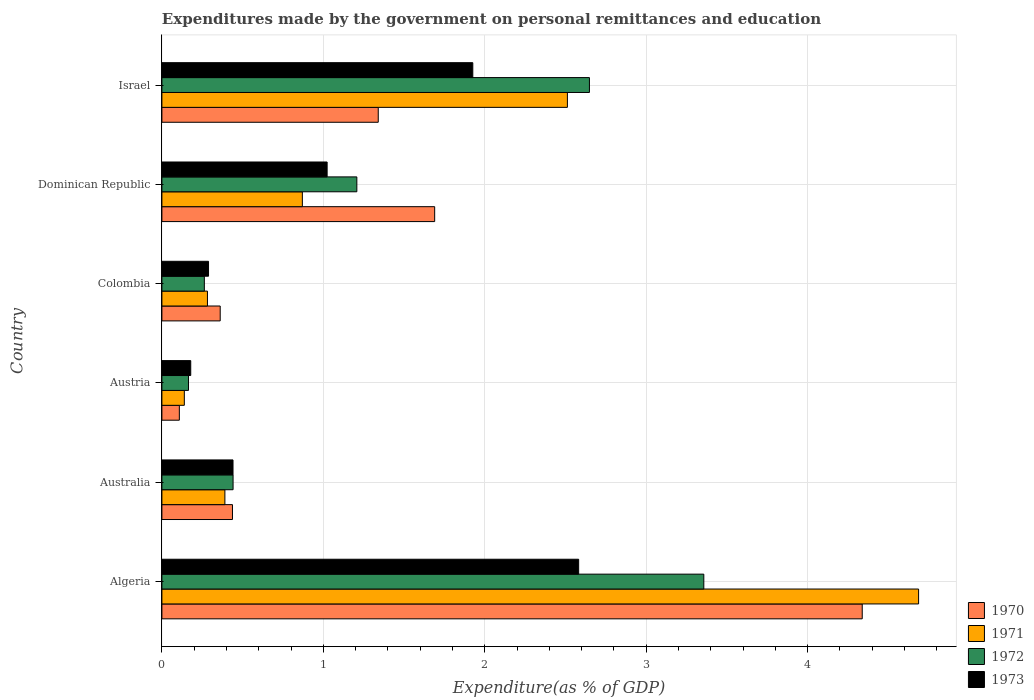Are the number of bars per tick equal to the number of legend labels?
Provide a succinct answer. Yes. How many bars are there on the 6th tick from the top?
Provide a short and direct response. 4. How many bars are there on the 4th tick from the bottom?
Offer a terse response. 4. What is the label of the 4th group of bars from the top?
Offer a very short reply. Austria. What is the expenditures made by the government on personal remittances and education in 1970 in Dominican Republic?
Your answer should be compact. 1.69. Across all countries, what is the maximum expenditures made by the government on personal remittances and education in 1973?
Ensure brevity in your answer.  2.58. Across all countries, what is the minimum expenditures made by the government on personal remittances and education in 1972?
Provide a short and direct response. 0.16. In which country was the expenditures made by the government on personal remittances and education in 1972 maximum?
Keep it short and to the point. Algeria. In which country was the expenditures made by the government on personal remittances and education in 1972 minimum?
Your answer should be very brief. Austria. What is the total expenditures made by the government on personal remittances and education in 1973 in the graph?
Keep it short and to the point. 6.44. What is the difference between the expenditures made by the government on personal remittances and education in 1970 in Australia and that in Austria?
Your answer should be very brief. 0.33. What is the difference between the expenditures made by the government on personal remittances and education in 1971 in Colombia and the expenditures made by the government on personal remittances and education in 1970 in Australia?
Offer a terse response. -0.16. What is the average expenditures made by the government on personal remittances and education in 1973 per country?
Give a very brief answer. 1.07. What is the difference between the expenditures made by the government on personal remittances and education in 1971 and expenditures made by the government on personal remittances and education in 1972 in Algeria?
Make the answer very short. 1.33. What is the ratio of the expenditures made by the government on personal remittances and education in 1971 in Australia to that in Colombia?
Your answer should be very brief. 1.38. Is the expenditures made by the government on personal remittances and education in 1970 in Australia less than that in Austria?
Keep it short and to the point. No. Is the difference between the expenditures made by the government on personal remittances and education in 1971 in Colombia and Dominican Republic greater than the difference between the expenditures made by the government on personal remittances and education in 1972 in Colombia and Dominican Republic?
Offer a very short reply. Yes. What is the difference between the highest and the second highest expenditures made by the government on personal remittances and education in 1971?
Keep it short and to the point. 2.18. What is the difference between the highest and the lowest expenditures made by the government on personal remittances and education in 1970?
Your response must be concise. 4.23. Is the sum of the expenditures made by the government on personal remittances and education in 1973 in Australia and Dominican Republic greater than the maximum expenditures made by the government on personal remittances and education in 1970 across all countries?
Offer a very short reply. No. What does the 3rd bar from the top in Australia represents?
Your answer should be compact. 1971. Are all the bars in the graph horizontal?
Keep it short and to the point. Yes. How many countries are there in the graph?
Provide a short and direct response. 6. What is the difference between two consecutive major ticks on the X-axis?
Make the answer very short. 1. Does the graph contain any zero values?
Keep it short and to the point. No. How many legend labels are there?
Your response must be concise. 4. How are the legend labels stacked?
Offer a terse response. Vertical. What is the title of the graph?
Your answer should be compact. Expenditures made by the government on personal remittances and education. What is the label or title of the X-axis?
Your response must be concise. Expenditure(as % of GDP). What is the Expenditure(as % of GDP) of 1970 in Algeria?
Provide a succinct answer. 4.34. What is the Expenditure(as % of GDP) in 1971 in Algeria?
Provide a short and direct response. 4.69. What is the Expenditure(as % of GDP) in 1972 in Algeria?
Give a very brief answer. 3.36. What is the Expenditure(as % of GDP) of 1973 in Algeria?
Offer a terse response. 2.58. What is the Expenditure(as % of GDP) of 1970 in Australia?
Provide a succinct answer. 0.44. What is the Expenditure(as % of GDP) of 1971 in Australia?
Provide a succinct answer. 0.39. What is the Expenditure(as % of GDP) of 1972 in Australia?
Keep it short and to the point. 0.44. What is the Expenditure(as % of GDP) in 1973 in Australia?
Your response must be concise. 0.44. What is the Expenditure(as % of GDP) of 1970 in Austria?
Your answer should be very brief. 0.11. What is the Expenditure(as % of GDP) in 1971 in Austria?
Ensure brevity in your answer.  0.14. What is the Expenditure(as % of GDP) of 1972 in Austria?
Make the answer very short. 0.16. What is the Expenditure(as % of GDP) of 1973 in Austria?
Make the answer very short. 0.18. What is the Expenditure(as % of GDP) in 1970 in Colombia?
Your response must be concise. 0.36. What is the Expenditure(as % of GDP) in 1971 in Colombia?
Keep it short and to the point. 0.28. What is the Expenditure(as % of GDP) in 1972 in Colombia?
Keep it short and to the point. 0.26. What is the Expenditure(as % of GDP) in 1973 in Colombia?
Keep it short and to the point. 0.29. What is the Expenditure(as % of GDP) in 1970 in Dominican Republic?
Give a very brief answer. 1.69. What is the Expenditure(as % of GDP) of 1971 in Dominican Republic?
Your response must be concise. 0.87. What is the Expenditure(as % of GDP) of 1972 in Dominican Republic?
Your answer should be compact. 1.21. What is the Expenditure(as % of GDP) of 1973 in Dominican Republic?
Your answer should be very brief. 1.02. What is the Expenditure(as % of GDP) of 1970 in Israel?
Offer a terse response. 1.34. What is the Expenditure(as % of GDP) in 1971 in Israel?
Provide a short and direct response. 2.51. What is the Expenditure(as % of GDP) of 1972 in Israel?
Offer a terse response. 2.65. What is the Expenditure(as % of GDP) of 1973 in Israel?
Offer a terse response. 1.93. Across all countries, what is the maximum Expenditure(as % of GDP) in 1970?
Provide a succinct answer. 4.34. Across all countries, what is the maximum Expenditure(as % of GDP) of 1971?
Provide a short and direct response. 4.69. Across all countries, what is the maximum Expenditure(as % of GDP) in 1972?
Your answer should be compact. 3.36. Across all countries, what is the maximum Expenditure(as % of GDP) in 1973?
Offer a terse response. 2.58. Across all countries, what is the minimum Expenditure(as % of GDP) of 1970?
Give a very brief answer. 0.11. Across all countries, what is the minimum Expenditure(as % of GDP) of 1971?
Make the answer very short. 0.14. Across all countries, what is the minimum Expenditure(as % of GDP) in 1972?
Provide a short and direct response. 0.16. Across all countries, what is the minimum Expenditure(as % of GDP) of 1973?
Make the answer very short. 0.18. What is the total Expenditure(as % of GDP) of 1970 in the graph?
Your answer should be compact. 8.27. What is the total Expenditure(as % of GDP) in 1971 in the graph?
Keep it short and to the point. 8.88. What is the total Expenditure(as % of GDP) of 1972 in the graph?
Offer a very short reply. 8.08. What is the total Expenditure(as % of GDP) in 1973 in the graph?
Ensure brevity in your answer.  6.44. What is the difference between the Expenditure(as % of GDP) in 1970 in Algeria and that in Australia?
Your response must be concise. 3.9. What is the difference between the Expenditure(as % of GDP) in 1971 in Algeria and that in Australia?
Your answer should be very brief. 4.3. What is the difference between the Expenditure(as % of GDP) of 1972 in Algeria and that in Australia?
Your response must be concise. 2.92. What is the difference between the Expenditure(as % of GDP) in 1973 in Algeria and that in Australia?
Keep it short and to the point. 2.14. What is the difference between the Expenditure(as % of GDP) in 1970 in Algeria and that in Austria?
Offer a terse response. 4.23. What is the difference between the Expenditure(as % of GDP) of 1971 in Algeria and that in Austria?
Provide a succinct answer. 4.55. What is the difference between the Expenditure(as % of GDP) in 1972 in Algeria and that in Austria?
Offer a terse response. 3.19. What is the difference between the Expenditure(as % of GDP) in 1973 in Algeria and that in Austria?
Your answer should be compact. 2.4. What is the difference between the Expenditure(as % of GDP) in 1970 in Algeria and that in Colombia?
Make the answer very short. 3.98. What is the difference between the Expenditure(as % of GDP) in 1971 in Algeria and that in Colombia?
Make the answer very short. 4.41. What is the difference between the Expenditure(as % of GDP) in 1972 in Algeria and that in Colombia?
Your answer should be compact. 3.09. What is the difference between the Expenditure(as % of GDP) in 1973 in Algeria and that in Colombia?
Provide a succinct answer. 2.29. What is the difference between the Expenditure(as % of GDP) in 1970 in Algeria and that in Dominican Republic?
Provide a succinct answer. 2.65. What is the difference between the Expenditure(as % of GDP) of 1971 in Algeria and that in Dominican Republic?
Offer a terse response. 3.82. What is the difference between the Expenditure(as % of GDP) of 1972 in Algeria and that in Dominican Republic?
Your response must be concise. 2.15. What is the difference between the Expenditure(as % of GDP) in 1973 in Algeria and that in Dominican Republic?
Ensure brevity in your answer.  1.56. What is the difference between the Expenditure(as % of GDP) of 1970 in Algeria and that in Israel?
Make the answer very short. 3. What is the difference between the Expenditure(as % of GDP) of 1971 in Algeria and that in Israel?
Give a very brief answer. 2.18. What is the difference between the Expenditure(as % of GDP) of 1972 in Algeria and that in Israel?
Offer a terse response. 0.71. What is the difference between the Expenditure(as % of GDP) in 1973 in Algeria and that in Israel?
Offer a very short reply. 0.66. What is the difference between the Expenditure(as % of GDP) in 1970 in Australia and that in Austria?
Ensure brevity in your answer.  0.33. What is the difference between the Expenditure(as % of GDP) in 1971 in Australia and that in Austria?
Ensure brevity in your answer.  0.25. What is the difference between the Expenditure(as % of GDP) in 1972 in Australia and that in Austria?
Make the answer very short. 0.28. What is the difference between the Expenditure(as % of GDP) in 1973 in Australia and that in Austria?
Offer a very short reply. 0.26. What is the difference between the Expenditure(as % of GDP) in 1970 in Australia and that in Colombia?
Offer a terse response. 0.08. What is the difference between the Expenditure(as % of GDP) of 1971 in Australia and that in Colombia?
Ensure brevity in your answer.  0.11. What is the difference between the Expenditure(as % of GDP) in 1972 in Australia and that in Colombia?
Ensure brevity in your answer.  0.18. What is the difference between the Expenditure(as % of GDP) of 1973 in Australia and that in Colombia?
Make the answer very short. 0.15. What is the difference between the Expenditure(as % of GDP) in 1970 in Australia and that in Dominican Republic?
Offer a very short reply. -1.25. What is the difference between the Expenditure(as % of GDP) of 1971 in Australia and that in Dominican Republic?
Make the answer very short. -0.48. What is the difference between the Expenditure(as % of GDP) in 1972 in Australia and that in Dominican Republic?
Make the answer very short. -0.77. What is the difference between the Expenditure(as % of GDP) in 1973 in Australia and that in Dominican Republic?
Provide a succinct answer. -0.58. What is the difference between the Expenditure(as % of GDP) in 1970 in Australia and that in Israel?
Your answer should be very brief. -0.9. What is the difference between the Expenditure(as % of GDP) of 1971 in Australia and that in Israel?
Offer a very short reply. -2.12. What is the difference between the Expenditure(as % of GDP) in 1972 in Australia and that in Israel?
Make the answer very short. -2.21. What is the difference between the Expenditure(as % of GDP) of 1973 in Australia and that in Israel?
Your response must be concise. -1.49. What is the difference between the Expenditure(as % of GDP) in 1970 in Austria and that in Colombia?
Provide a short and direct response. -0.25. What is the difference between the Expenditure(as % of GDP) of 1971 in Austria and that in Colombia?
Offer a very short reply. -0.14. What is the difference between the Expenditure(as % of GDP) of 1972 in Austria and that in Colombia?
Keep it short and to the point. -0.1. What is the difference between the Expenditure(as % of GDP) in 1973 in Austria and that in Colombia?
Ensure brevity in your answer.  -0.11. What is the difference between the Expenditure(as % of GDP) in 1970 in Austria and that in Dominican Republic?
Your answer should be very brief. -1.58. What is the difference between the Expenditure(as % of GDP) in 1971 in Austria and that in Dominican Republic?
Keep it short and to the point. -0.73. What is the difference between the Expenditure(as % of GDP) in 1972 in Austria and that in Dominican Republic?
Offer a terse response. -1.04. What is the difference between the Expenditure(as % of GDP) of 1973 in Austria and that in Dominican Republic?
Keep it short and to the point. -0.84. What is the difference between the Expenditure(as % of GDP) in 1970 in Austria and that in Israel?
Keep it short and to the point. -1.23. What is the difference between the Expenditure(as % of GDP) of 1971 in Austria and that in Israel?
Ensure brevity in your answer.  -2.37. What is the difference between the Expenditure(as % of GDP) of 1972 in Austria and that in Israel?
Your answer should be compact. -2.48. What is the difference between the Expenditure(as % of GDP) in 1973 in Austria and that in Israel?
Offer a terse response. -1.75. What is the difference between the Expenditure(as % of GDP) of 1970 in Colombia and that in Dominican Republic?
Offer a very short reply. -1.33. What is the difference between the Expenditure(as % of GDP) of 1971 in Colombia and that in Dominican Republic?
Offer a terse response. -0.59. What is the difference between the Expenditure(as % of GDP) of 1972 in Colombia and that in Dominican Republic?
Offer a terse response. -0.94. What is the difference between the Expenditure(as % of GDP) of 1973 in Colombia and that in Dominican Republic?
Your answer should be very brief. -0.73. What is the difference between the Expenditure(as % of GDP) of 1970 in Colombia and that in Israel?
Your answer should be compact. -0.98. What is the difference between the Expenditure(as % of GDP) in 1971 in Colombia and that in Israel?
Offer a terse response. -2.23. What is the difference between the Expenditure(as % of GDP) of 1972 in Colombia and that in Israel?
Offer a terse response. -2.39. What is the difference between the Expenditure(as % of GDP) of 1973 in Colombia and that in Israel?
Provide a succinct answer. -1.64. What is the difference between the Expenditure(as % of GDP) in 1970 in Dominican Republic and that in Israel?
Your answer should be compact. 0.35. What is the difference between the Expenditure(as % of GDP) of 1971 in Dominican Republic and that in Israel?
Give a very brief answer. -1.64. What is the difference between the Expenditure(as % of GDP) of 1972 in Dominican Republic and that in Israel?
Keep it short and to the point. -1.44. What is the difference between the Expenditure(as % of GDP) of 1973 in Dominican Republic and that in Israel?
Keep it short and to the point. -0.9. What is the difference between the Expenditure(as % of GDP) of 1970 in Algeria and the Expenditure(as % of GDP) of 1971 in Australia?
Ensure brevity in your answer.  3.95. What is the difference between the Expenditure(as % of GDP) of 1970 in Algeria and the Expenditure(as % of GDP) of 1972 in Australia?
Provide a short and direct response. 3.9. What is the difference between the Expenditure(as % of GDP) of 1970 in Algeria and the Expenditure(as % of GDP) of 1973 in Australia?
Provide a short and direct response. 3.9. What is the difference between the Expenditure(as % of GDP) of 1971 in Algeria and the Expenditure(as % of GDP) of 1972 in Australia?
Your answer should be compact. 4.25. What is the difference between the Expenditure(as % of GDP) in 1971 in Algeria and the Expenditure(as % of GDP) in 1973 in Australia?
Offer a terse response. 4.25. What is the difference between the Expenditure(as % of GDP) in 1972 in Algeria and the Expenditure(as % of GDP) in 1973 in Australia?
Give a very brief answer. 2.92. What is the difference between the Expenditure(as % of GDP) of 1970 in Algeria and the Expenditure(as % of GDP) of 1971 in Austria?
Make the answer very short. 4.2. What is the difference between the Expenditure(as % of GDP) of 1970 in Algeria and the Expenditure(as % of GDP) of 1972 in Austria?
Your response must be concise. 4.17. What is the difference between the Expenditure(as % of GDP) in 1970 in Algeria and the Expenditure(as % of GDP) in 1973 in Austria?
Your answer should be compact. 4.16. What is the difference between the Expenditure(as % of GDP) in 1971 in Algeria and the Expenditure(as % of GDP) in 1972 in Austria?
Your response must be concise. 4.52. What is the difference between the Expenditure(as % of GDP) in 1971 in Algeria and the Expenditure(as % of GDP) in 1973 in Austria?
Your answer should be very brief. 4.51. What is the difference between the Expenditure(as % of GDP) of 1972 in Algeria and the Expenditure(as % of GDP) of 1973 in Austria?
Provide a short and direct response. 3.18. What is the difference between the Expenditure(as % of GDP) in 1970 in Algeria and the Expenditure(as % of GDP) in 1971 in Colombia?
Your answer should be very brief. 4.06. What is the difference between the Expenditure(as % of GDP) in 1970 in Algeria and the Expenditure(as % of GDP) in 1972 in Colombia?
Keep it short and to the point. 4.08. What is the difference between the Expenditure(as % of GDP) in 1970 in Algeria and the Expenditure(as % of GDP) in 1973 in Colombia?
Your answer should be compact. 4.05. What is the difference between the Expenditure(as % of GDP) of 1971 in Algeria and the Expenditure(as % of GDP) of 1972 in Colombia?
Your response must be concise. 4.42. What is the difference between the Expenditure(as % of GDP) of 1971 in Algeria and the Expenditure(as % of GDP) of 1973 in Colombia?
Your response must be concise. 4.4. What is the difference between the Expenditure(as % of GDP) in 1972 in Algeria and the Expenditure(as % of GDP) in 1973 in Colombia?
Provide a short and direct response. 3.07. What is the difference between the Expenditure(as % of GDP) in 1970 in Algeria and the Expenditure(as % of GDP) in 1971 in Dominican Republic?
Make the answer very short. 3.47. What is the difference between the Expenditure(as % of GDP) in 1970 in Algeria and the Expenditure(as % of GDP) in 1972 in Dominican Republic?
Make the answer very short. 3.13. What is the difference between the Expenditure(as % of GDP) of 1970 in Algeria and the Expenditure(as % of GDP) of 1973 in Dominican Republic?
Keep it short and to the point. 3.31. What is the difference between the Expenditure(as % of GDP) in 1971 in Algeria and the Expenditure(as % of GDP) in 1972 in Dominican Republic?
Your answer should be compact. 3.48. What is the difference between the Expenditure(as % of GDP) of 1971 in Algeria and the Expenditure(as % of GDP) of 1973 in Dominican Republic?
Make the answer very short. 3.66. What is the difference between the Expenditure(as % of GDP) in 1972 in Algeria and the Expenditure(as % of GDP) in 1973 in Dominican Republic?
Keep it short and to the point. 2.33. What is the difference between the Expenditure(as % of GDP) in 1970 in Algeria and the Expenditure(as % of GDP) in 1971 in Israel?
Offer a terse response. 1.83. What is the difference between the Expenditure(as % of GDP) in 1970 in Algeria and the Expenditure(as % of GDP) in 1972 in Israel?
Make the answer very short. 1.69. What is the difference between the Expenditure(as % of GDP) of 1970 in Algeria and the Expenditure(as % of GDP) of 1973 in Israel?
Your answer should be very brief. 2.41. What is the difference between the Expenditure(as % of GDP) of 1971 in Algeria and the Expenditure(as % of GDP) of 1972 in Israel?
Your answer should be very brief. 2.04. What is the difference between the Expenditure(as % of GDP) of 1971 in Algeria and the Expenditure(as % of GDP) of 1973 in Israel?
Provide a succinct answer. 2.76. What is the difference between the Expenditure(as % of GDP) in 1972 in Algeria and the Expenditure(as % of GDP) in 1973 in Israel?
Provide a short and direct response. 1.43. What is the difference between the Expenditure(as % of GDP) in 1970 in Australia and the Expenditure(as % of GDP) in 1971 in Austria?
Your response must be concise. 0.3. What is the difference between the Expenditure(as % of GDP) in 1970 in Australia and the Expenditure(as % of GDP) in 1972 in Austria?
Your answer should be compact. 0.27. What is the difference between the Expenditure(as % of GDP) in 1970 in Australia and the Expenditure(as % of GDP) in 1973 in Austria?
Your response must be concise. 0.26. What is the difference between the Expenditure(as % of GDP) in 1971 in Australia and the Expenditure(as % of GDP) in 1972 in Austria?
Offer a very short reply. 0.23. What is the difference between the Expenditure(as % of GDP) of 1971 in Australia and the Expenditure(as % of GDP) of 1973 in Austria?
Your answer should be compact. 0.21. What is the difference between the Expenditure(as % of GDP) of 1972 in Australia and the Expenditure(as % of GDP) of 1973 in Austria?
Make the answer very short. 0.26. What is the difference between the Expenditure(as % of GDP) in 1970 in Australia and the Expenditure(as % of GDP) in 1971 in Colombia?
Offer a terse response. 0.15. What is the difference between the Expenditure(as % of GDP) in 1970 in Australia and the Expenditure(as % of GDP) in 1972 in Colombia?
Make the answer very short. 0.17. What is the difference between the Expenditure(as % of GDP) of 1970 in Australia and the Expenditure(as % of GDP) of 1973 in Colombia?
Offer a very short reply. 0.15. What is the difference between the Expenditure(as % of GDP) of 1971 in Australia and the Expenditure(as % of GDP) of 1972 in Colombia?
Provide a short and direct response. 0.13. What is the difference between the Expenditure(as % of GDP) in 1971 in Australia and the Expenditure(as % of GDP) in 1973 in Colombia?
Your answer should be compact. 0.1. What is the difference between the Expenditure(as % of GDP) in 1972 in Australia and the Expenditure(as % of GDP) in 1973 in Colombia?
Your answer should be very brief. 0.15. What is the difference between the Expenditure(as % of GDP) of 1970 in Australia and the Expenditure(as % of GDP) of 1971 in Dominican Republic?
Provide a succinct answer. -0.43. What is the difference between the Expenditure(as % of GDP) of 1970 in Australia and the Expenditure(as % of GDP) of 1972 in Dominican Republic?
Provide a succinct answer. -0.77. What is the difference between the Expenditure(as % of GDP) in 1970 in Australia and the Expenditure(as % of GDP) in 1973 in Dominican Republic?
Keep it short and to the point. -0.59. What is the difference between the Expenditure(as % of GDP) of 1971 in Australia and the Expenditure(as % of GDP) of 1972 in Dominican Republic?
Provide a succinct answer. -0.82. What is the difference between the Expenditure(as % of GDP) in 1971 in Australia and the Expenditure(as % of GDP) in 1973 in Dominican Republic?
Keep it short and to the point. -0.63. What is the difference between the Expenditure(as % of GDP) of 1972 in Australia and the Expenditure(as % of GDP) of 1973 in Dominican Republic?
Offer a very short reply. -0.58. What is the difference between the Expenditure(as % of GDP) in 1970 in Australia and the Expenditure(as % of GDP) in 1971 in Israel?
Offer a very short reply. -2.07. What is the difference between the Expenditure(as % of GDP) in 1970 in Australia and the Expenditure(as % of GDP) in 1972 in Israel?
Your response must be concise. -2.21. What is the difference between the Expenditure(as % of GDP) of 1970 in Australia and the Expenditure(as % of GDP) of 1973 in Israel?
Provide a short and direct response. -1.49. What is the difference between the Expenditure(as % of GDP) in 1971 in Australia and the Expenditure(as % of GDP) in 1972 in Israel?
Ensure brevity in your answer.  -2.26. What is the difference between the Expenditure(as % of GDP) of 1971 in Australia and the Expenditure(as % of GDP) of 1973 in Israel?
Ensure brevity in your answer.  -1.54. What is the difference between the Expenditure(as % of GDP) in 1972 in Australia and the Expenditure(as % of GDP) in 1973 in Israel?
Provide a short and direct response. -1.49. What is the difference between the Expenditure(as % of GDP) in 1970 in Austria and the Expenditure(as % of GDP) in 1971 in Colombia?
Offer a very short reply. -0.17. What is the difference between the Expenditure(as % of GDP) of 1970 in Austria and the Expenditure(as % of GDP) of 1972 in Colombia?
Your response must be concise. -0.15. What is the difference between the Expenditure(as % of GDP) in 1970 in Austria and the Expenditure(as % of GDP) in 1973 in Colombia?
Your answer should be very brief. -0.18. What is the difference between the Expenditure(as % of GDP) in 1971 in Austria and the Expenditure(as % of GDP) in 1972 in Colombia?
Your response must be concise. -0.12. What is the difference between the Expenditure(as % of GDP) in 1971 in Austria and the Expenditure(as % of GDP) in 1973 in Colombia?
Your response must be concise. -0.15. What is the difference between the Expenditure(as % of GDP) in 1972 in Austria and the Expenditure(as % of GDP) in 1973 in Colombia?
Ensure brevity in your answer.  -0.12. What is the difference between the Expenditure(as % of GDP) in 1970 in Austria and the Expenditure(as % of GDP) in 1971 in Dominican Republic?
Ensure brevity in your answer.  -0.76. What is the difference between the Expenditure(as % of GDP) of 1970 in Austria and the Expenditure(as % of GDP) of 1972 in Dominican Republic?
Offer a very short reply. -1.1. What is the difference between the Expenditure(as % of GDP) of 1970 in Austria and the Expenditure(as % of GDP) of 1973 in Dominican Republic?
Your answer should be compact. -0.92. What is the difference between the Expenditure(as % of GDP) of 1971 in Austria and the Expenditure(as % of GDP) of 1972 in Dominican Republic?
Give a very brief answer. -1.07. What is the difference between the Expenditure(as % of GDP) of 1971 in Austria and the Expenditure(as % of GDP) of 1973 in Dominican Republic?
Offer a very short reply. -0.88. What is the difference between the Expenditure(as % of GDP) of 1972 in Austria and the Expenditure(as % of GDP) of 1973 in Dominican Republic?
Your answer should be very brief. -0.86. What is the difference between the Expenditure(as % of GDP) in 1970 in Austria and the Expenditure(as % of GDP) in 1971 in Israel?
Provide a short and direct response. -2.4. What is the difference between the Expenditure(as % of GDP) of 1970 in Austria and the Expenditure(as % of GDP) of 1972 in Israel?
Your response must be concise. -2.54. What is the difference between the Expenditure(as % of GDP) of 1970 in Austria and the Expenditure(as % of GDP) of 1973 in Israel?
Your answer should be very brief. -1.82. What is the difference between the Expenditure(as % of GDP) of 1971 in Austria and the Expenditure(as % of GDP) of 1972 in Israel?
Your response must be concise. -2.51. What is the difference between the Expenditure(as % of GDP) of 1971 in Austria and the Expenditure(as % of GDP) of 1973 in Israel?
Provide a short and direct response. -1.79. What is the difference between the Expenditure(as % of GDP) of 1972 in Austria and the Expenditure(as % of GDP) of 1973 in Israel?
Provide a short and direct response. -1.76. What is the difference between the Expenditure(as % of GDP) in 1970 in Colombia and the Expenditure(as % of GDP) in 1971 in Dominican Republic?
Offer a very short reply. -0.51. What is the difference between the Expenditure(as % of GDP) in 1970 in Colombia and the Expenditure(as % of GDP) in 1972 in Dominican Republic?
Your answer should be very brief. -0.85. What is the difference between the Expenditure(as % of GDP) in 1970 in Colombia and the Expenditure(as % of GDP) in 1973 in Dominican Republic?
Keep it short and to the point. -0.66. What is the difference between the Expenditure(as % of GDP) of 1971 in Colombia and the Expenditure(as % of GDP) of 1972 in Dominican Republic?
Provide a succinct answer. -0.93. What is the difference between the Expenditure(as % of GDP) in 1971 in Colombia and the Expenditure(as % of GDP) in 1973 in Dominican Republic?
Provide a short and direct response. -0.74. What is the difference between the Expenditure(as % of GDP) in 1972 in Colombia and the Expenditure(as % of GDP) in 1973 in Dominican Republic?
Offer a terse response. -0.76. What is the difference between the Expenditure(as % of GDP) in 1970 in Colombia and the Expenditure(as % of GDP) in 1971 in Israel?
Offer a terse response. -2.15. What is the difference between the Expenditure(as % of GDP) of 1970 in Colombia and the Expenditure(as % of GDP) of 1972 in Israel?
Provide a succinct answer. -2.29. What is the difference between the Expenditure(as % of GDP) in 1970 in Colombia and the Expenditure(as % of GDP) in 1973 in Israel?
Provide a succinct answer. -1.56. What is the difference between the Expenditure(as % of GDP) of 1971 in Colombia and the Expenditure(as % of GDP) of 1972 in Israel?
Keep it short and to the point. -2.37. What is the difference between the Expenditure(as % of GDP) of 1971 in Colombia and the Expenditure(as % of GDP) of 1973 in Israel?
Provide a short and direct response. -1.64. What is the difference between the Expenditure(as % of GDP) in 1972 in Colombia and the Expenditure(as % of GDP) in 1973 in Israel?
Your response must be concise. -1.66. What is the difference between the Expenditure(as % of GDP) in 1970 in Dominican Republic and the Expenditure(as % of GDP) in 1971 in Israel?
Make the answer very short. -0.82. What is the difference between the Expenditure(as % of GDP) of 1970 in Dominican Republic and the Expenditure(as % of GDP) of 1972 in Israel?
Keep it short and to the point. -0.96. What is the difference between the Expenditure(as % of GDP) in 1970 in Dominican Republic and the Expenditure(as % of GDP) in 1973 in Israel?
Your answer should be compact. -0.24. What is the difference between the Expenditure(as % of GDP) of 1971 in Dominican Republic and the Expenditure(as % of GDP) of 1972 in Israel?
Ensure brevity in your answer.  -1.78. What is the difference between the Expenditure(as % of GDP) of 1971 in Dominican Republic and the Expenditure(as % of GDP) of 1973 in Israel?
Keep it short and to the point. -1.06. What is the difference between the Expenditure(as % of GDP) of 1972 in Dominican Republic and the Expenditure(as % of GDP) of 1973 in Israel?
Offer a very short reply. -0.72. What is the average Expenditure(as % of GDP) in 1970 per country?
Provide a short and direct response. 1.38. What is the average Expenditure(as % of GDP) in 1971 per country?
Provide a short and direct response. 1.48. What is the average Expenditure(as % of GDP) of 1972 per country?
Give a very brief answer. 1.35. What is the average Expenditure(as % of GDP) of 1973 per country?
Your answer should be compact. 1.07. What is the difference between the Expenditure(as % of GDP) of 1970 and Expenditure(as % of GDP) of 1971 in Algeria?
Offer a very short reply. -0.35. What is the difference between the Expenditure(as % of GDP) in 1970 and Expenditure(as % of GDP) in 1972 in Algeria?
Make the answer very short. 0.98. What is the difference between the Expenditure(as % of GDP) in 1970 and Expenditure(as % of GDP) in 1973 in Algeria?
Ensure brevity in your answer.  1.76. What is the difference between the Expenditure(as % of GDP) in 1971 and Expenditure(as % of GDP) in 1972 in Algeria?
Give a very brief answer. 1.33. What is the difference between the Expenditure(as % of GDP) in 1971 and Expenditure(as % of GDP) in 1973 in Algeria?
Your response must be concise. 2.11. What is the difference between the Expenditure(as % of GDP) in 1972 and Expenditure(as % of GDP) in 1973 in Algeria?
Provide a short and direct response. 0.78. What is the difference between the Expenditure(as % of GDP) in 1970 and Expenditure(as % of GDP) in 1971 in Australia?
Give a very brief answer. 0.05. What is the difference between the Expenditure(as % of GDP) of 1970 and Expenditure(as % of GDP) of 1972 in Australia?
Offer a terse response. -0. What is the difference between the Expenditure(as % of GDP) of 1970 and Expenditure(as % of GDP) of 1973 in Australia?
Provide a short and direct response. -0. What is the difference between the Expenditure(as % of GDP) of 1971 and Expenditure(as % of GDP) of 1972 in Australia?
Your answer should be compact. -0.05. What is the difference between the Expenditure(as % of GDP) in 1971 and Expenditure(as % of GDP) in 1973 in Australia?
Ensure brevity in your answer.  -0.05. What is the difference between the Expenditure(as % of GDP) in 1972 and Expenditure(as % of GDP) in 1973 in Australia?
Keep it short and to the point. 0. What is the difference between the Expenditure(as % of GDP) of 1970 and Expenditure(as % of GDP) of 1971 in Austria?
Your answer should be compact. -0.03. What is the difference between the Expenditure(as % of GDP) of 1970 and Expenditure(as % of GDP) of 1972 in Austria?
Give a very brief answer. -0.06. What is the difference between the Expenditure(as % of GDP) in 1970 and Expenditure(as % of GDP) in 1973 in Austria?
Keep it short and to the point. -0.07. What is the difference between the Expenditure(as % of GDP) of 1971 and Expenditure(as % of GDP) of 1972 in Austria?
Offer a terse response. -0.03. What is the difference between the Expenditure(as % of GDP) of 1971 and Expenditure(as % of GDP) of 1973 in Austria?
Give a very brief answer. -0.04. What is the difference between the Expenditure(as % of GDP) of 1972 and Expenditure(as % of GDP) of 1973 in Austria?
Provide a short and direct response. -0.01. What is the difference between the Expenditure(as % of GDP) in 1970 and Expenditure(as % of GDP) in 1971 in Colombia?
Your answer should be compact. 0.08. What is the difference between the Expenditure(as % of GDP) in 1970 and Expenditure(as % of GDP) in 1972 in Colombia?
Keep it short and to the point. 0.1. What is the difference between the Expenditure(as % of GDP) of 1970 and Expenditure(as % of GDP) of 1973 in Colombia?
Ensure brevity in your answer.  0.07. What is the difference between the Expenditure(as % of GDP) of 1971 and Expenditure(as % of GDP) of 1972 in Colombia?
Your response must be concise. 0.02. What is the difference between the Expenditure(as % of GDP) of 1971 and Expenditure(as % of GDP) of 1973 in Colombia?
Give a very brief answer. -0.01. What is the difference between the Expenditure(as % of GDP) of 1972 and Expenditure(as % of GDP) of 1973 in Colombia?
Keep it short and to the point. -0.03. What is the difference between the Expenditure(as % of GDP) in 1970 and Expenditure(as % of GDP) in 1971 in Dominican Republic?
Provide a short and direct response. 0.82. What is the difference between the Expenditure(as % of GDP) of 1970 and Expenditure(as % of GDP) of 1972 in Dominican Republic?
Ensure brevity in your answer.  0.48. What is the difference between the Expenditure(as % of GDP) in 1970 and Expenditure(as % of GDP) in 1973 in Dominican Republic?
Provide a succinct answer. 0.67. What is the difference between the Expenditure(as % of GDP) in 1971 and Expenditure(as % of GDP) in 1972 in Dominican Republic?
Provide a succinct answer. -0.34. What is the difference between the Expenditure(as % of GDP) in 1971 and Expenditure(as % of GDP) in 1973 in Dominican Republic?
Offer a terse response. -0.15. What is the difference between the Expenditure(as % of GDP) of 1972 and Expenditure(as % of GDP) of 1973 in Dominican Republic?
Offer a terse response. 0.18. What is the difference between the Expenditure(as % of GDP) in 1970 and Expenditure(as % of GDP) in 1971 in Israel?
Your answer should be very brief. -1.17. What is the difference between the Expenditure(as % of GDP) in 1970 and Expenditure(as % of GDP) in 1972 in Israel?
Keep it short and to the point. -1.31. What is the difference between the Expenditure(as % of GDP) of 1970 and Expenditure(as % of GDP) of 1973 in Israel?
Provide a short and direct response. -0.59. What is the difference between the Expenditure(as % of GDP) of 1971 and Expenditure(as % of GDP) of 1972 in Israel?
Ensure brevity in your answer.  -0.14. What is the difference between the Expenditure(as % of GDP) in 1971 and Expenditure(as % of GDP) in 1973 in Israel?
Ensure brevity in your answer.  0.59. What is the difference between the Expenditure(as % of GDP) of 1972 and Expenditure(as % of GDP) of 1973 in Israel?
Keep it short and to the point. 0.72. What is the ratio of the Expenditure(as % of GDP) in 1970 in Algeria to that in Australia?
Provide a short and direct response. 9.92. What is the ratio of the Expenditure(as % of GDP) in 1971 in Algeria to that in Australia?
Give a very brief answer. 12.01. What is the ratio of the Expenditure(as % of GDP) of 1972 in Algeria to that in Australia?
Provide a succinct answer. 7.61. What is the ratio of the Expenditure(as % of GDP) of 1973 in Algeria to that in Australia?
Provide a short and direct response. 5.86. What is the ratio of the Expenditure(as % of GDP) of 1970 in Algeria to that in Austria?
Provide a short and direct response. 40.14. What is the ratio of the Expenditure(as % of GDP) in 1971 in Algeria to that in Austria?
Give a very brief answer. 33.73. What is the ratio of the Expenditure(as % of GDP) of 1972 in Algeria to that in Austria?
Make the answer very short. 20.38. What is the ratio of the Expenditure(as % of GDP) in 1973 in Algeria to that in Austria?
Your response must be concise. 14.45. What is the ratio of the Expenditure(as % of GDP) in 1970 in Algeria to that in Colombia?
Provide a short and direct response. 12.01. What is the ratio of the Expenditure(as % of GDP) of 1971 in Algeria to that in Colombia?
Ensure brevity in your answer.  16.61. What is the ratio of the Expenditure(as % of GDP) of 1972 in Algeria to that in Colombia?
Your response must be concise. 12.77. What is the ratio of the Expenditure(as % of GDP) of 1973 in Algeria to that in Colombia?
Your answer should be compact. 8.94. What is the ratio of the Expenditure(as % of GDP) of 1970 in Algeria to that in Dominican Republic?
Make the answer very short. 2.57. What is the ratio of the Expenditure(as % of GDP) in 1971 in Algeria to that in Dominican Republic?
Give a very brief answer. 5.39. What is the ratio of the Expenditure(as % of GDP) in 1972 in Algeria to that in Dominican Republic?
Provide a succinct answer. 2.78. What is the ratio of the Expenditure(as % of GDP) in 1973 in Algeria to that in Dominican Republic?
Offer a terse response. 2.52. What is the ratio of the Expenditure(as % of GDP) in 1970 in Algeria to that in Israel?
Provide a short and direct response. 3.24. What is the ratio of the Expenditure(as % of GDP) in 1971 in Algeria to that in Israel?
Offer a terse response. 1.87. What is the ratio of the Expenditure(as % of GDP) of 1972 in Algeria to that in Israel?
Offer a very short reply. 1.27. What is the ratio of the Expenditure(as % of GDP) of 1973 in Algeria to that in Israel?
Provide a succinct answer. 1.34. What is the ratio of the Expenditure(as % of GDP) in 1970 in Australia to that in Austria?
Provide a short and direct response. 4.04. What is the ratio of the Expenditure(as % of GDP) in 1971 in Australia to that in Austria?
Offer a terse response. 2.81. What is the ratio of the Expenditure(as % of GDP) in 1972 in Australia to that in Austria?
Offer a terse response. 2.68. What is the ratio of the Expenditure(as % of GDP) in 1973 in Australia to that in Austria?
Your response must be concise. 2.47. What is the ratio of the Expenditure(as % of GDP) of 1970 in Australia to that in Colombia?
Keep it short and to the point. 1.21. What is the ratio of the Expenditure(as % of GDP) of 1971 in Australia to that in Colombia?
Offer a very short reply. 1.38. What is the ratio of the Expenditure(as % of GDP) of 1972 in Australia to that in Colombia?
Your answer should be compact. 1.68. What is the ratio of the Expenditure(as % of GDP) of 1973 in Australia to that in Colombia?
Provide a short and direct response. 1.52. What is the ratio of the Expenditure(as % of GDP) of 1970 in Australia to that in Dominican Republic?
Make the answer very short. 0.26. What is the ratio of the Expenditure(as % of GDP) in 1971 in Australia to that in Dominican Republic?
Your answer should be very brief. 0.45. What is the ratio of the Expenditure(as % of GDP) in 1972 in Australia to that in Dominican Republic?
Make the answer very short. 0.37. What is the ratio of the Expenditure(as % of GDP) of 1973 in Australia to that in Dominican Republic?
Provide a succinct answer. 0.43. What is the ratio of the Expenditure(as % of GDP) of 1970 in Australia to that in Israel?
Provide a succinct answer. 0.33. What is the ratio of the Expenditure(as % of GDP) in 1971 in Australia to that in Israel?
Keep it short and to the point. 0.16. What is the ratio of the Expenditure(as % of GDP) in 1972 in Australia to that in Israel?
Give a very brief answer. 0.17. What is the ratio of the Expenditure(as % of GDP) of 1973 in Australia to that in Israel?
Keep it short and to the point. 0.23. What is the ratio of the Expenditure(as % of GDP) of 1970 in Austria to that in Colombia?
Your answer should be very brief. 0.3. What is the ratio of the Expenditure(as % of GDP) in 1971 in Austria to that in Colombia?
Ensure brevity in your answer.  0.49. What is the ratio of the Expenditure(as % of GDP) in 1972 in Austria to that in Colombia?
Your response must be concise. 0.63. What is the ratio of the Expenditure(as % of GDP) of 1973 in Austria to that in Colombia?
Ensure brevity in your answer.  0.62. What is the ratio of the Expenditure(as % of GDP) of 1970 in Austria to that in Dominican Republic?
Provide a succinct answer. 0.06. What is the ratio of the Expenditure(as % of GDP) of 1971 in Austria to that in Dominican Republic?
Ensure brevity in your answer.  0.16. What is the ratio of the Expenditure(as % of GDP) of 1972 in Austria to that in Dominican Republic?
Make the answer very short. 0.14. What is the ratio of the Expenditure(as % of GDP) of 1973 in Austria to that in Dominican Republic?
Ensure brevity in your answer.  0.17. What is the ratio of the Expenditure(as % of GDP) of 1970 in Austria to that in Israel?
Provide a short and direct response. 0.08. What is the ratio of the Expenditure(as % of GDP) of 1971 in Austria to that in Israel?
Offer a very short reply. 0.06. What is the ratio of the Expenditure(as % of GDP) of 1972 in Austria to that in Israel?
Offer a terse response. 0.06. What is the ratio of the Expenditure(as % of GDP) in 1973 in Austria to that in Israel?
Ensure brevity in your answer.  0.09. What is the ratio of the Expenditure(as % of GDP) of 1970 in Colombia to that in Dominican Republic?
Keep it short and to the point. 0.21. What is the ratio of the Expenditure(as % of GDP) of 1971 in Colombia to that in Dominican Republic?
Your response must be concise. 0.32. What is the ratio of the Expenditure(as % of GDP) of 1972 in Colombia to that in Dominican Republic?
Your answer should be very brief. 0.22. What is the ratio of the Expenditure(as % of GDP) in 1973 in Colombia to that in Dominican Republic?
Your response must be concise. 0.28. What is the ratio of the Expenditure(as % of GDP) of 1970 in Colombia to that in Israel?
Keep it short and to the point. 0.27. What is the ratio of the Expenditure(as % of GDP) of 1971 in Colombia to that in Israel?
Offer a very short reply. 0.11. What is the ratio of the Expenditure(as % of GDP) of 1972 in Colombia to that in Israel?
Offer a terse response. 0.1. What is the ratio of the Expenditure(as % of GDP) of 1973 in Colombia to that in Israel?
Make the answer very short. 0.15. What is the ratio of the Expenditure(as % of GDP) in 1970 in Dominican Republic to that in Israel?
Offer a terse response. 1.26. What is the ratio of the Expenditure(as % of GDP) of 1971 in Dominican Republic to that in Israel?
Your answer should be very brief. 0.35. What is the ratio of the Expenditure(as % of GDP) in 1972 in Dominican Republic to that in Israel?
Give a very brief answer. 0.46. What is the ratio of the Expenditure(as % of GDP) of 1973 in Dominican Republic to that in Israel?
Provide a short and direct response. 0.53. What is the difference between the highest and the second highest Expenditure(as % of GDP) in 1970?
Keep it short and to the point. 2.65. What is the difference between the highest and the second highest Expenditure(as % of GDP) of 1971?
Offer a very short reply. 2.18. What is the difference between the highest and the second highest Expenditure(as % of GDP) of 1972?
Provide a short and direct response. 0.71. What is the difference between the highest and the second highest Expenditure(as % of GDP) in 1973?
Offer a terse response. 0.66. What is the difference between the highest and the lowest Expenditure(as % of GDP) in 1970?
Your response must be concise. 4.23. What is the difference between the highest and the lowest Expenditure(as % of GDP) of 1971?
Provide a succinct answer. 4.55. What is the difference between the highest and the lowest Expenditure(as % of GDP) of 1972?
Offer a very short reply. 3.19. What is the difference between the highest and the lowest Expenditure(as % of GDP) of 1973?
Your answer should be very brief. 2.4. 